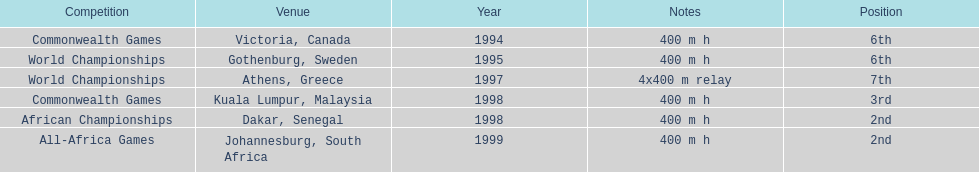What is the ultimate competition on the diagram? All-Africa Games. 